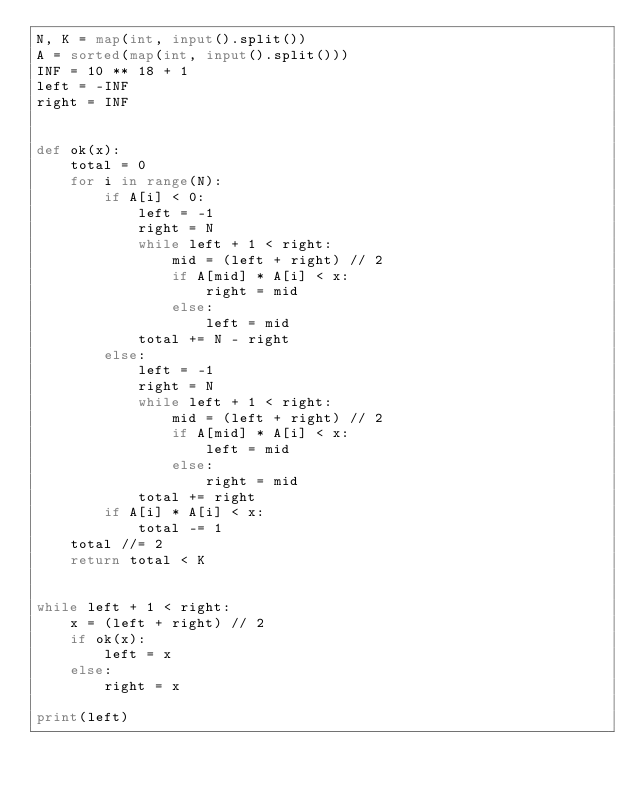<code> <loc_0><loc_0><loc_500><loc_500><_Python_>N, K = map(int, input().split())
A = sorted(map(int, input().split()))
INF = 10 ** 18 + 1
left = -INF
right = INF


def ok(x):
    total = 0
    for i in range(N):
        if A[i] < 0:
            left = -1
            right = N
            while left + 1 < right:
                mid = (left + right) // 2
                if A[mid] * A[i] < x:
                    right = mid
                else:
                    left = mid
            total += N - right
        else:
            left = -1
            right = N
            while left + 1 < right:
                mid = (left + right) // 2
                if A[mid] * A[i] < x:
                    left = mid
                else:
                    right = mid
            total += right
        if A[i] * A[i] < x:
            total -= 1
    total //= 2
    return total < K


while left + 1 < right:
    x = (left + right) // 2
    if ok(x):
        left = x
    else:
        right = x

print(left)
</code> 